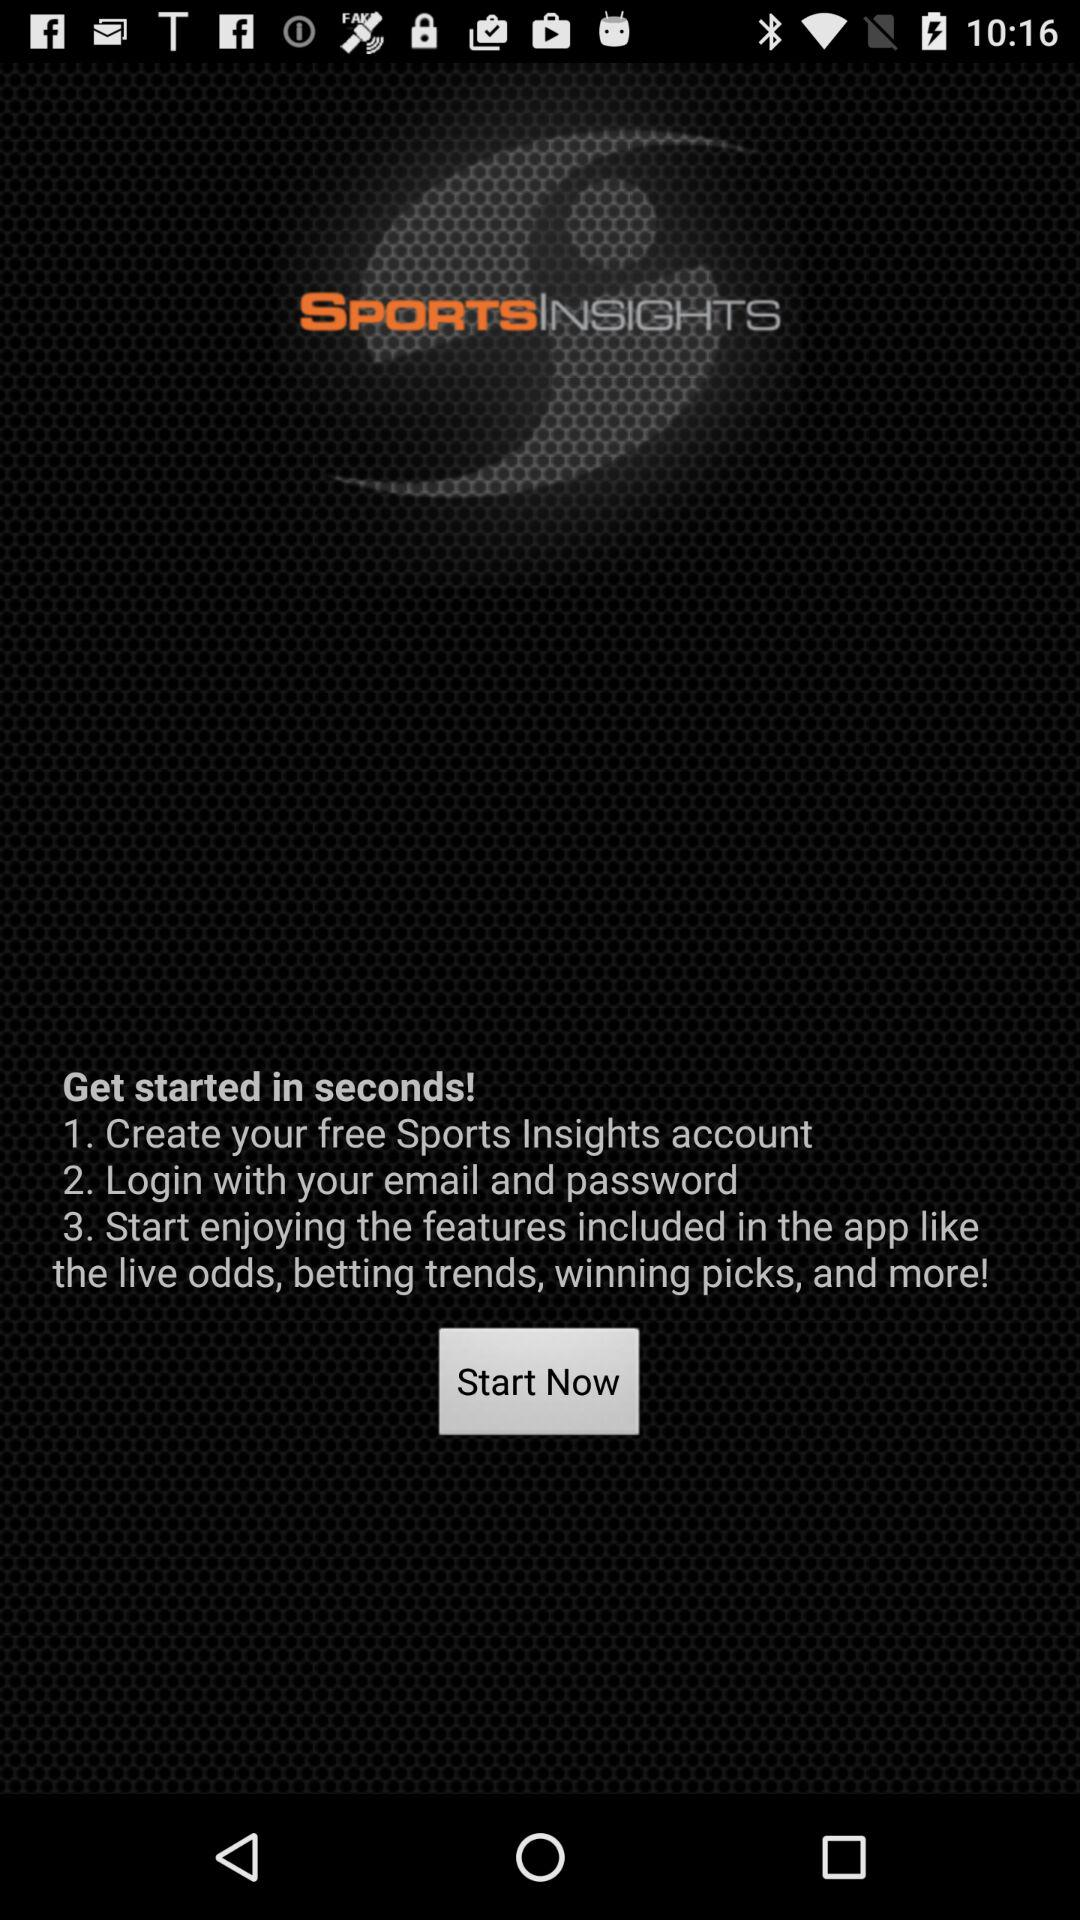How many steps are in the process of starting with Sports Insights?
Answer the question using a single word or phrase. 3 